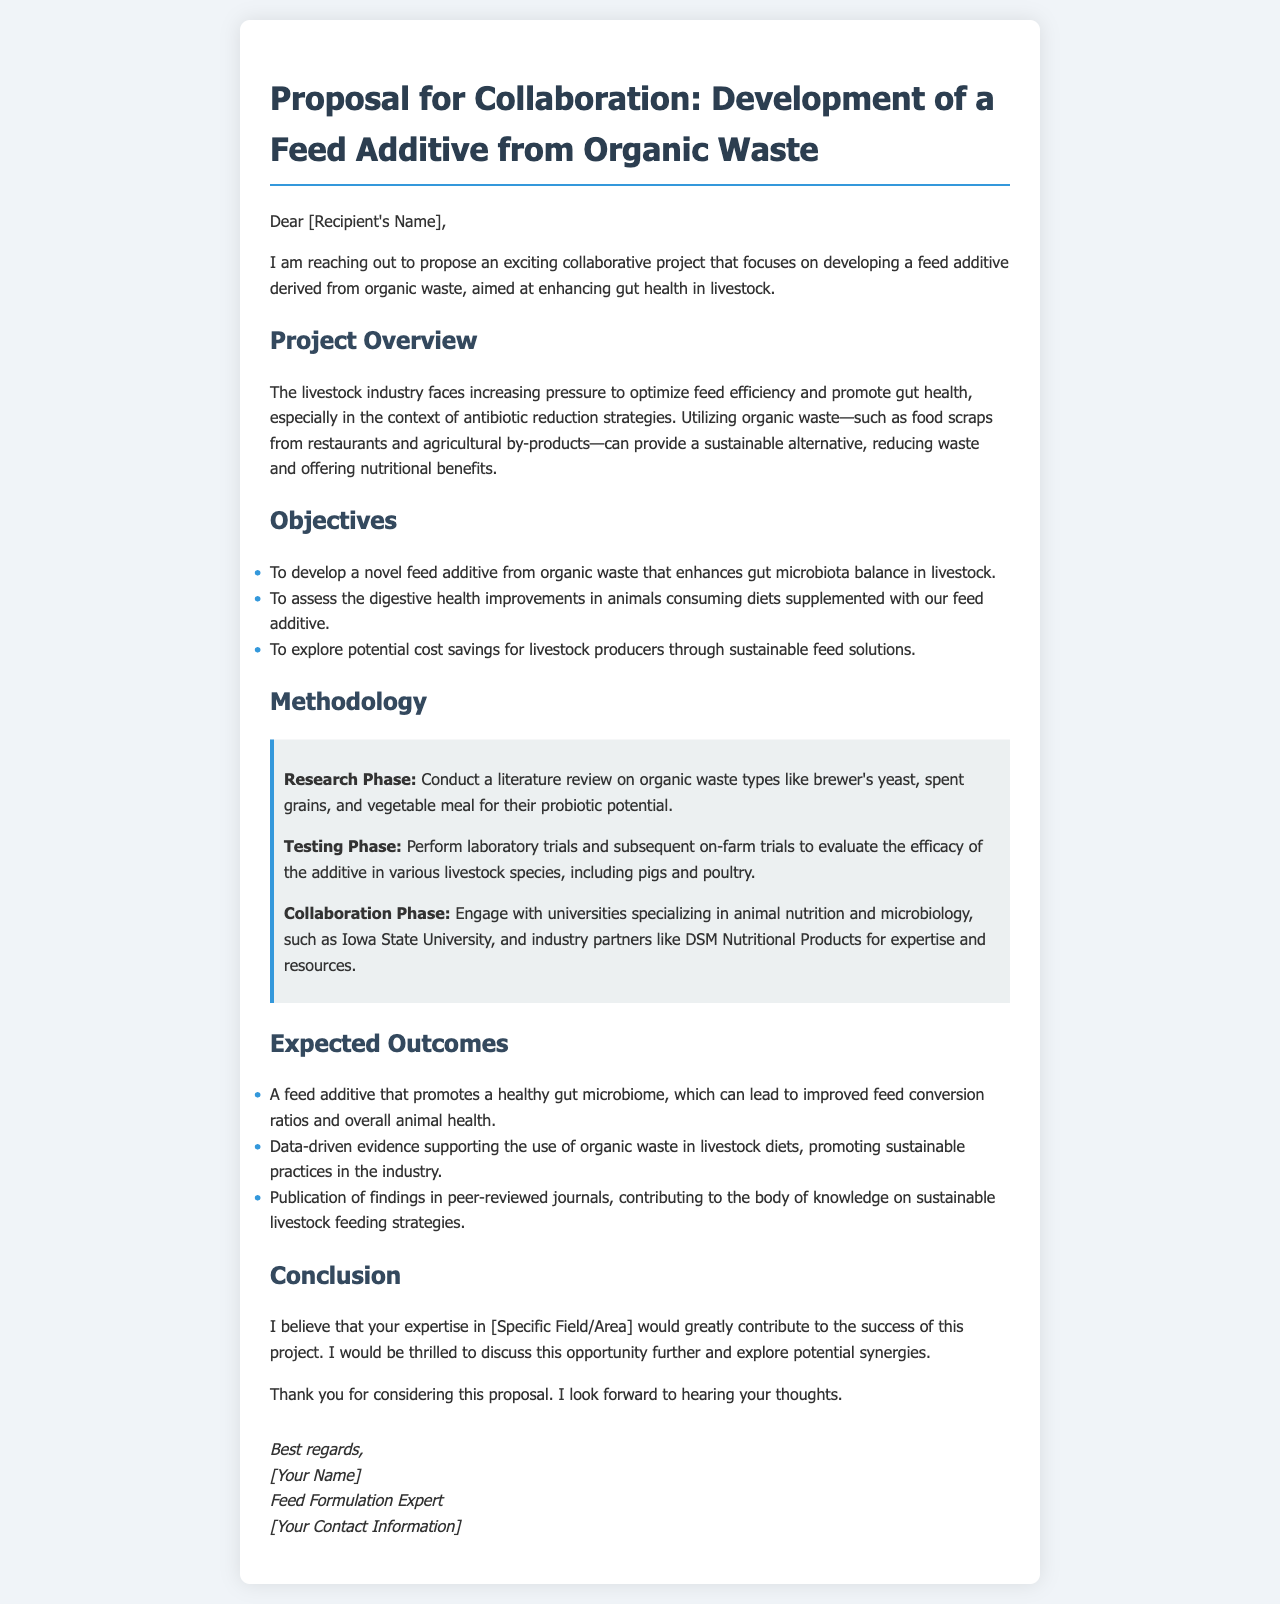What is the main focus of the proposed project? The project focuses on developing a feed additive derived from organic waste to enhance gut health in livestock.
Answer: Feed additive derived from organic waste Who is the intended recipient of the proposal? The proposal is addressed to a specific individual, indicated by a placeholder for the recipient's name.
Answer: [Recipient's Name] Which university is mentioned for collaboration in the project? The document mentions Iowa State University as a university specializing in animal nutrition and microbiology.
Answer: Iowa State University What are the three main objectives of the project? The objectives include developing a feed additive, assessing digestive health improvements, and exploring cost savings.
Answer: Develop a novel feed additive, assess digestive health improvements, explore cost savings What is one expected outcome of the project? One expected outcome is the promotion of a healthy gut microbiome, which can lead to improved feed conversion ratios.
Answer: A feed additive that promotes a healthy gut microbiome What phase involves laboratory trials? The Testing Phase is the phase that involves laboratory trials and subsequent on-farm trials.
Answer: Testing Phase What type of document is this proposal? The document is a proposal for collaboration for a specific project.
Answer: Proposal for Collaboration What aspect of the livestock industry does this project address? The project addresses the optimization of feed efficiency and promotion of gut health in livestock.
Answer: Optimization of feed efficiency and promotion of gut health 